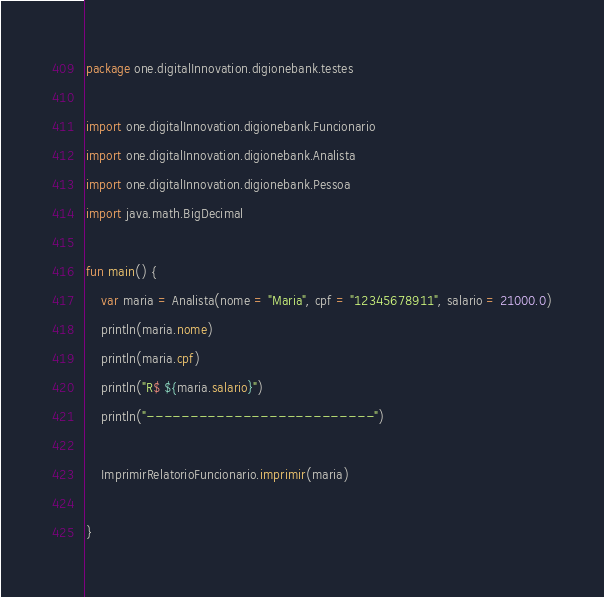Convert code to text. <code><loc_0><loc_0><loc_500><loc_500><_Kotlin_>package one.digitalInnovation.digionebank.testes

import one.digitalInnovation.digionebank.Funcionario
import one.digitalInnovation.digionebank.Analista
import one.digitalInnovation.digionebank.Pessoa
import java.math.BigDecimal

fun main() {
    var maria = Analista(nome = "Maria", cpf = "12345678911", salario = 21000.0)
    println(maria.nome)
    println(maria.cpf)
    println("R$ ${maria.salario}")
    println("--------------------------")

    ImprimirRelatorioFuncionario.imprimir(maria)

}</code> 